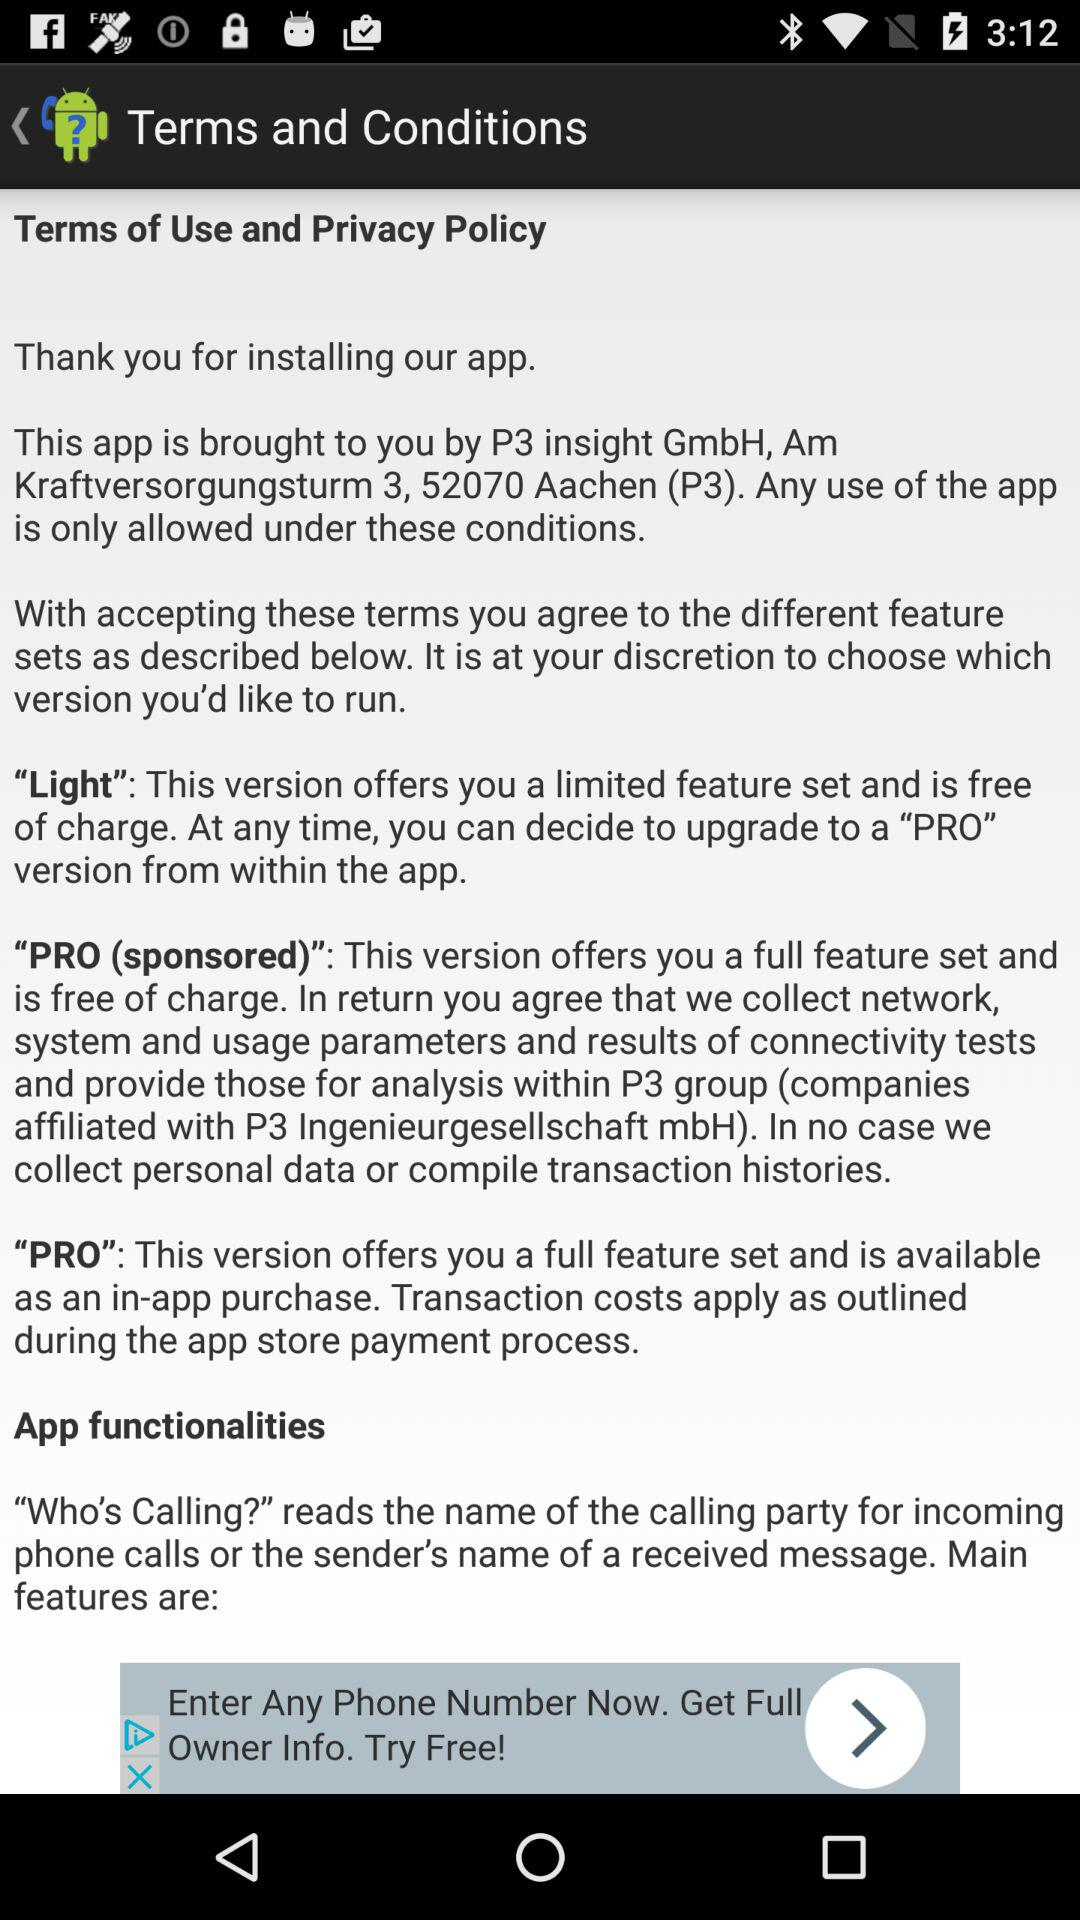How many versions of the app are available?
Answer the question using a single word or phrase. 3 